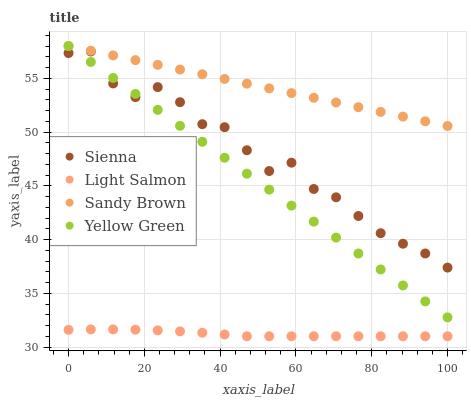Does Light Salmon have the minimum area under the curve?
Answer yes or no. Yes. Does Sandy Brown have the maximum area under the curve?
Answer yes or no. Yes. Does Sandy Brown have the minimum area under the curve?
Answer yes or no. No. Does Light Salmon have the maximum area under the curve?
Answer yes or no. No. Is Sandy Brown the smoothest?
Answer yes or no. Yes. Is Sienna the roughest?
Answer yes or no. Yes. Is Light Salmon the smoothest?
Answer yes or no. No. Is Light Salmon the roughest?
Answer yes or no. No. Does Light Salmon have the lowest value?
Answer yes or no. Yes. Does Sandy Brown have the lowest value?
Answer yes or no. No. Does Yellow Green have the highest value?
Answer yes or no. Yes. Does Light Salmon have the highest value?
Answer yes or no. No. Is Light Salmon less than Sandy Brown?
Answer yes or no. Yes. Is Sienna greater than Light Salmon?
Answer yes or no. Yes. Does Sienna intersect Yellow Green?
Answer yes or no. Yes. Is Sienna less than Yellow Green?
Answer yes or no. No. Is Sienna greater than Yellow Green?
Answer yes or no. No. Does Light Salmon intersect Sandy Brown?
Answer yes or no. No. 